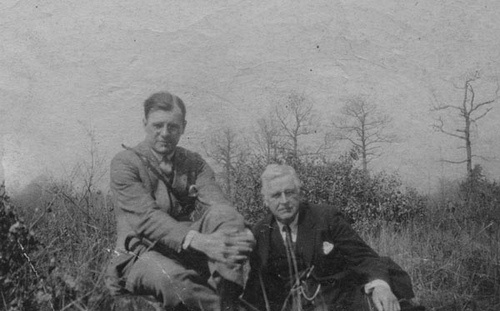Describe the objects in this image and their specific colors. I can see people in lightgray, gray, and black tones, people in black, gray, and lightgray tones, tie in gray, black, and lightgray tones, and tie in gray, black, and lightgray tones in this image. 